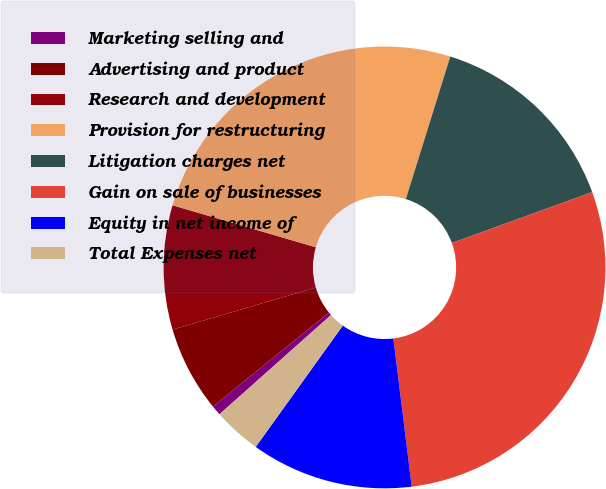<chart> <loc_0><loc_0><loc_500><loc_500><pie_chart><fcel>Marketing selling and<fcel>Advertising and product<fcel>Research and development<fcel>Provision for restructuring<fcel>Litigation charges net<fcel>Gain on sale of businesses<fcel>Equity in net income of<fcel>Total Expenses net<nl><fcel>0.73%<fcel>6.3%<fcel>9.08%<fcel>25.27%<fcel>14.65%<fcel>28.57%<fcel>11.87%<fcel>3.52%<nl></chart> 